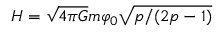Convert formula to latex. <formula><loc_0><loc_0><loc_500><loc_500>H = \sqrt { 4 \pi G } m \varphi _ { 0 } \sqrt { p / ( 2 p - 1 ) }</formula> 